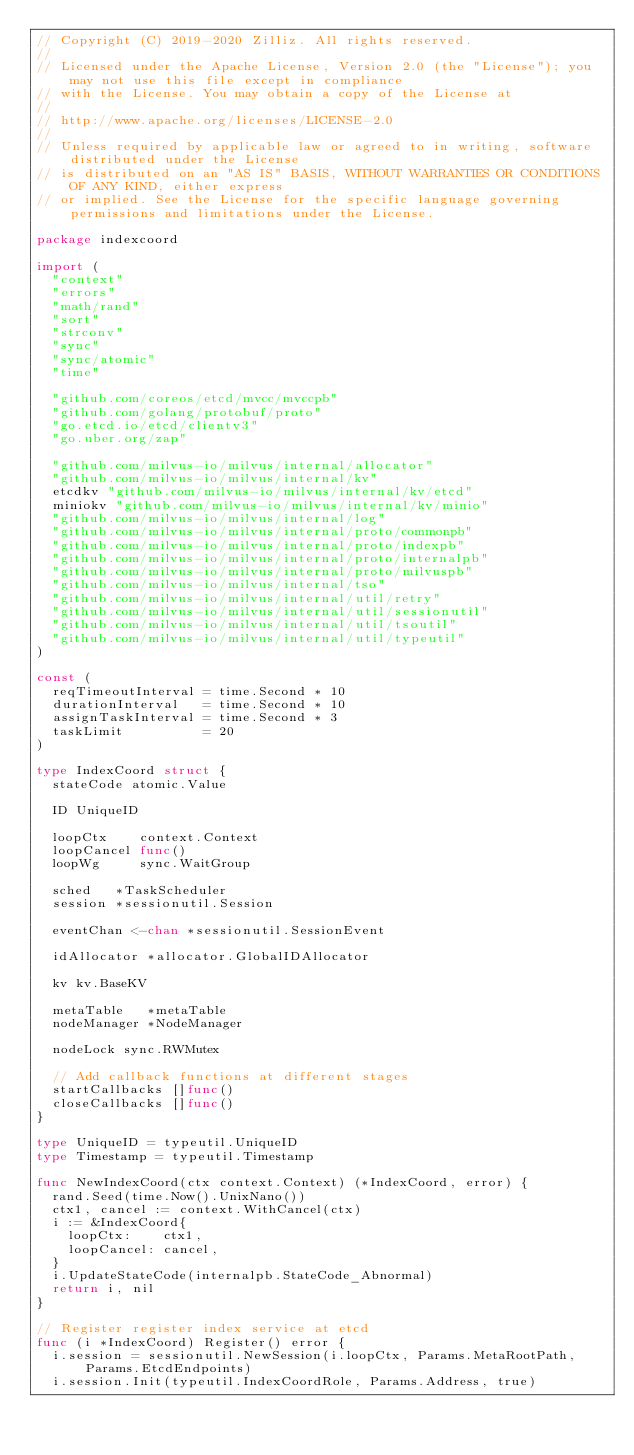Convert code to text. <code><loc_0><loc_0><loc_500><loc_500><_Go_>// Copyright (C) 2019-2020 Zilliz. All rights reserved.
//
// Licensed under the Apache License, Version 2.0 (the "License"); you may not use this file except in compliance
// with the License. You may obtain a copy of the License at
//
// http://www.apache.org/licenses/LICENSE-2.0
//
// Unless required by applicable law or agreed to in writing, software distributed under the License
// is distributed on an "AS IS" BASIS, WITHOUT WARRANTIES OR CONDITIONS OF ANY KIND, either express
// or implied. See the License for the specific language governing permissions and limitations under the License.

package indexcoord

import (
	"context"
	"errors"
	"math/rand"
	"sort"
	"strconv"
	"sync"
	"sync/atomic"
	"time"

	"github.com/coreos/etcd/mvcc/mvccpb"
	"github.com/golang/protobuf/proto"
	"go.etcd.io/etcd/clientv3"
	"go.uber.org/zap"

	"github.com/milvus-io/milvus/internal/allocator"
	"github.com/milvus-io/milvus/internal/kv"
	etcdkv "github.com/milvus-io/milvus/internal/kv/etcd"
	miniokv "github.com/milvus-io/milvus/internal/kv/minio"
	"github.com/milvus-io/milvus/internal/log"
	"github.com/milvus-io/milvus/internal/proto/commonpb"
	"github.com/milvus-io/milvus/internal/proto/indexpb"
	"github.com/milvus-io/milvus/internal/proto/internalpb"
	"github.com/milvus-io/milvus/internal/proto/milvuspb"
	"github.com/milvus-io/milvus/internal/tso"
	"github.com/milvus-io/milvus/internal/util/retry"
	"github.com/milvus-io/milvus/internal/util/sessionutil"
	"github.com/milvus-io/milvus/internal/util/tsoutil"
	"github.com/milvus-io/milvus/internal/util/typeutil"
)

const (
	reqTimeoutInterval = time.Second * 10
	durationInterval   = time.Second * 10
	assignTaskInterval = time.Second * 3
	taskLimit          = 20
)

type IndexCoord struct {
	stateCode atomic.Value

	ID UniqueID

	loopCtx    context.Context
	loopCancel func()
	loopWg     sync.WaitGroup

	sched   *TaskScheduler
	session *sessionutil.Session

	eventChan <-chan *sessionutil.SessionEvent

	idAllocator *allocator.GlobalIDAllocator

	kv kv.BaseKV

	metaTable   *metaTable
	nodeManager *NodeManager

	nodeLock sync.RWMutex

	// Add callback functions at different stages
	startCallbacks []func()
	closeCallbacks []func()
}

type UniqueID = typeutil.UniqueID
type Timestamp = typeutil.Timestamp

func NewIndexCoord(ctx context.Context) (*IndexCoord, error) {
	rand.Seed(time.Now().UnixNano())
	ctx1, cancel := context.WithCancel(ctx)
	i := &IndexCoord{
		loopCtx:    ctx1,
		loopCancel: cancel,
	}
	i.UpdateStateCode(internalpb.StateCode_Abnormal)
	return i, nil
}

// Register register index service at etcd
func (i *IndexCoord) Register() error {
	i.session = sessionutil.NewSession(i.loopCtx, Params.MetaRootPath, Params.EtcdEndpoints)
	i.session.Init(typeutil.IndexCoordRole, Params.Address, true)</code> 